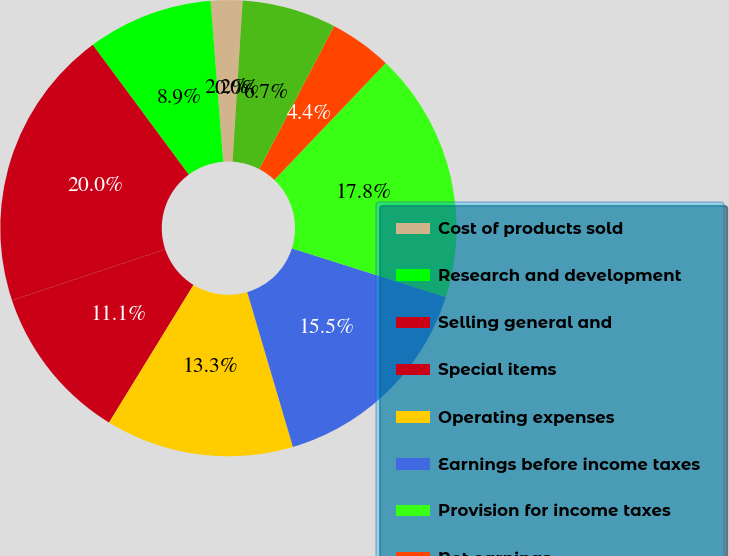Convert chart. <chart><loc_0><loc_0><loc_500><loc_500><pie_chart><fcel>Cost of products sold<fcel>Research and development<fcel>Selling general and<fcel>Special items<fcel>Operating expenses<fcel>Earnings before income taxes<fcel>Provision for income taxes<fcel>Net earnings<fcel>Net Earnings of Zimmer<fcel>Earnings Per Common Share -<nl><fcel>2.23%<fcel>8.89%<fcel>19.99%<fcel>11.11%<fcel>13.33%<fcel>15.55%<fcel>17.77%<fcel>4.45%<fcel>6.67%<fcel>0.01%<nl></chart> 